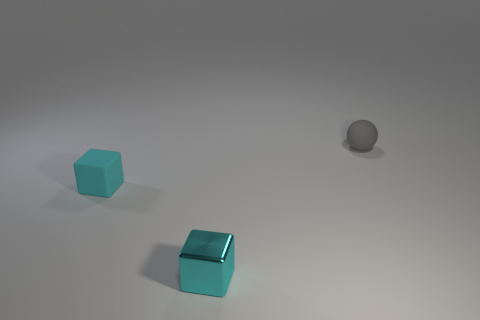Do the thing behind the cyan matte thing and the tiny cyan metallic object have the same shape?
Make the answer very short. No. How many green things are either large things or shiny cubes?
Your answer should be very brief. 0. Are there an equal number of tiny spheres that are in front of the matte block and blocks to the right of the tiny gray rubber ball?
Your answer should be compact. Yes. What is the color of the small object that is on the left side of the cube that is in front of the small rubber thing that is left of the gray thing?
Your answer should be compact. Cyan. Are there any other things of the same color as the small metal block?
Provide a succinct answer. Yes. The small object that is the same color as the small matte cube is what shape?
Your answer should be compact. Cube. There is a shiny object that is the same size as the gray sphere; what is its shape?
Make the answer very short. Cube. Is the material of the small cyan cube right of the cyan matte cube the same as the small cyan object behind the tiny cyan shiny block?
Your answer should be compact. No. What material is the cube in front of the rubber object that is in front of the small gray sphere?
Offer a terse response. Metal. How big is the matte object on the left side of the gray sphere that is behind the small matte thing that is left of the gray matte thing?
Provide a short and direct response. Small. 